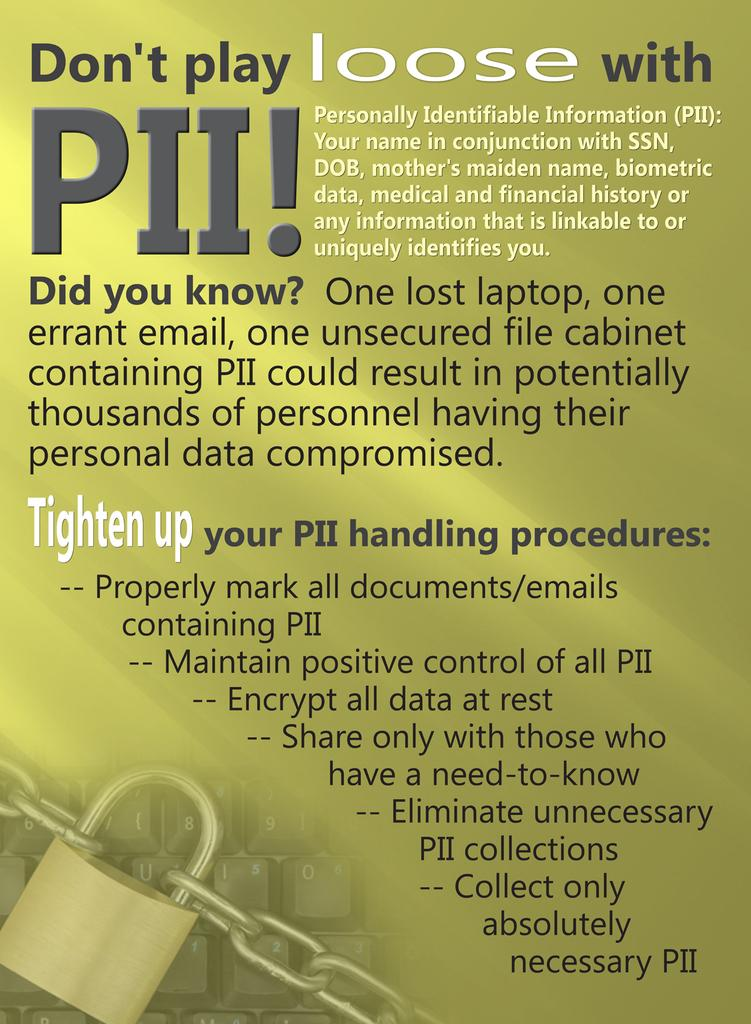<image>
Write a terse but informative summary of the picture. a paper that says 'don't play loose with pii!' on it 